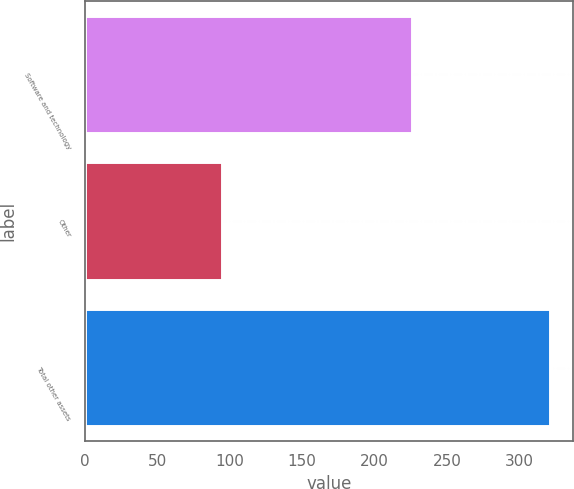Convert chart. <chart><loc_0><loc_0><loc_500><loc_500><bar_chart><fcel>Software and technology<fcel>Other<fcel>Total other assets<nl><fcel>226<fcel>95<fcel>321<nl></chart> 